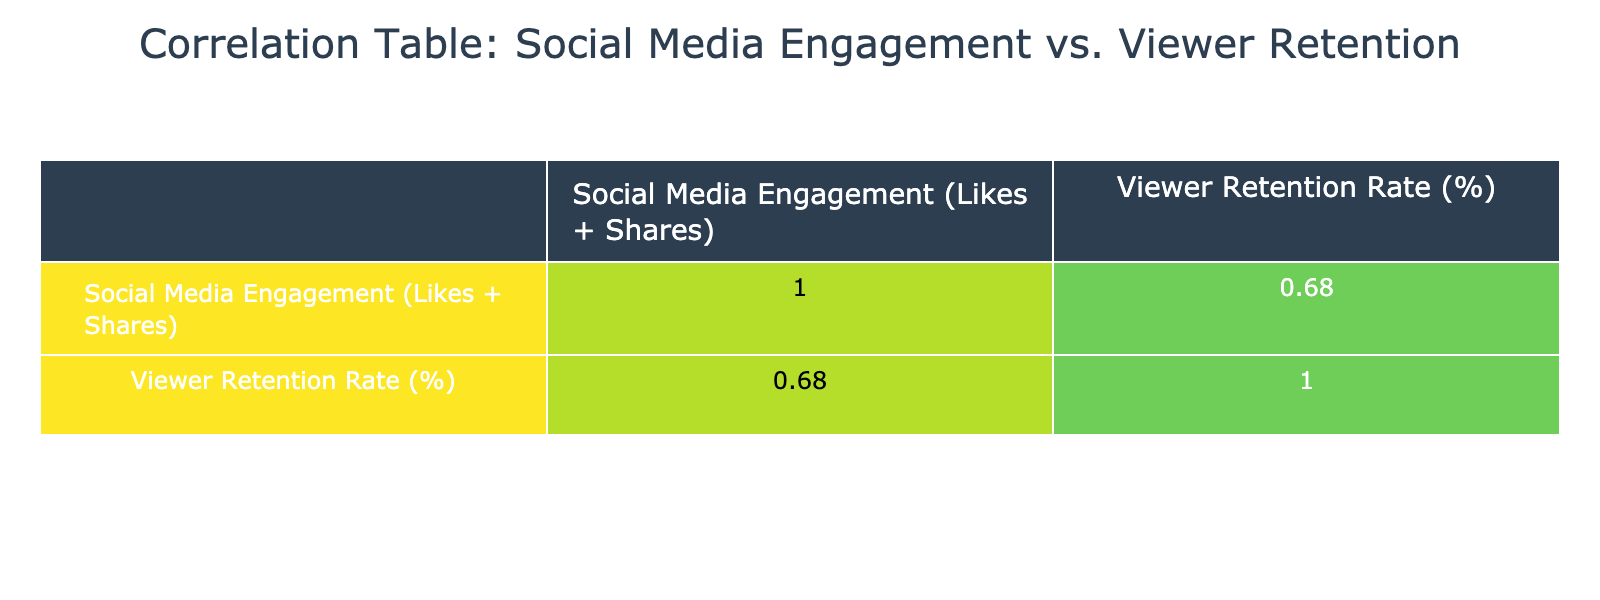What is the viewer retention rate for "Money Heist"? From the table, we can find the row for "Money Heist" and see that the viewer retention rate is listed as 91%.
Answer: 91% Which show has the highest social media engagement? By examining the Social Media Engagement column, "Money Heist" has the highest value at 2500000, making it the show with the most engagement.
Answer: Money Heist Is the viewer retention rate higher for "Breaking Bad" compared to "Euphoria"? Looking at the viewer retention rates, "Breaking Bad" has a rate of 90% and "Euphoria" has a rate of 86%. Since 90% is greater than 86%, the answer is yes.
Answer: Yes What is the average viewer retention rate for all the shows listed? To find the average, we sum the viewer retention rates: 90 + 85 + 88 + 80 + 82 + 87 + 84 + 86 + 89 + 91 = 870. There are 10 shows, so the average is 870 / 10 = 87%.
Answer: 87% Is the correlation between social media engagement and viewer retention positive? The correlation value in the table indicates how these two variables relate. If the correlation coefficient is positive, that implies a positive correlation. The positive number suggests that higher engagement is related to higher retention.
Answer: Yes What is the retention rate difference between "The Crown" and "Ozark"? "The Crown" has a retention rate of 85% and "Ozark" has a retention rate of 82%. The difference is 85% - 82% = 3%.
Answer: 3% How many shows have a viewer retention rate that is 85% or higher? By inspecting the viewer retention rates, the shows with rates 85% or more are "Breaking Bad," "Money Heist," "Better Call Saul," "Stranger Things," "The Queen's Gambit," "Euphoria," and "The Crown." That totals to 7 shows.
Answer: 7 Which two shows have the closest viewer retention rates? Looking at the viewer retention rates, "Ozark" has 82% and "The Handmaid's Tale" has 80%, making the difference only 2%. Therefore, they are the closest in terms of retention rates.
Answer: Ozark and The Handmaid's Tale What relationship can be inferred from the values of social media engagement and viewer retention based on the table data? The correlation coefficient will show how the two variables are related. A positive relationship indicates that as social media engagement increases, viewer retention tends to increase as well.
Answer: Positive relationship 